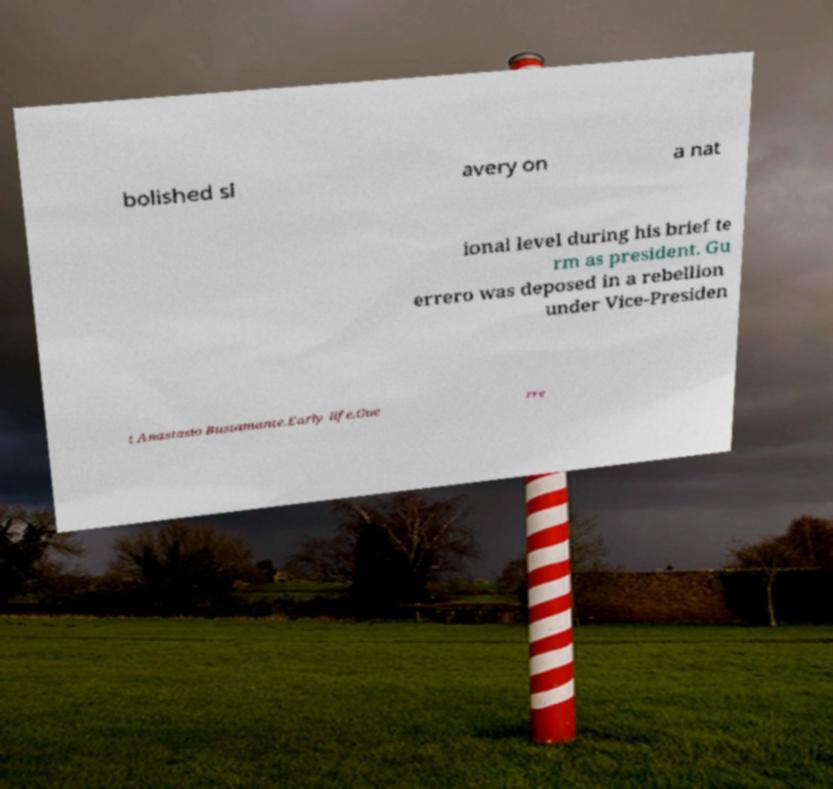What messages or text are displayed in this image? I need them in a readable, typed format. bolished sl avery on a nat ional level during his brief te rm as president. Gu errero was deposed in a rebellion under Vice-Presiden t Anastasio Bustamante.Early life.Gue rre 